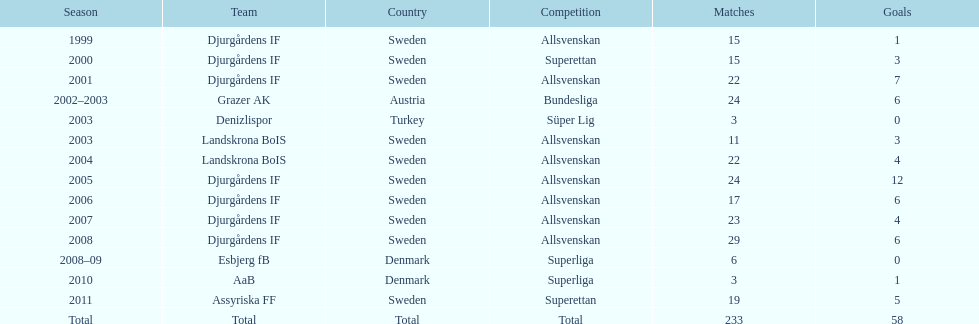What is the overall count of matches that took place? 233. 